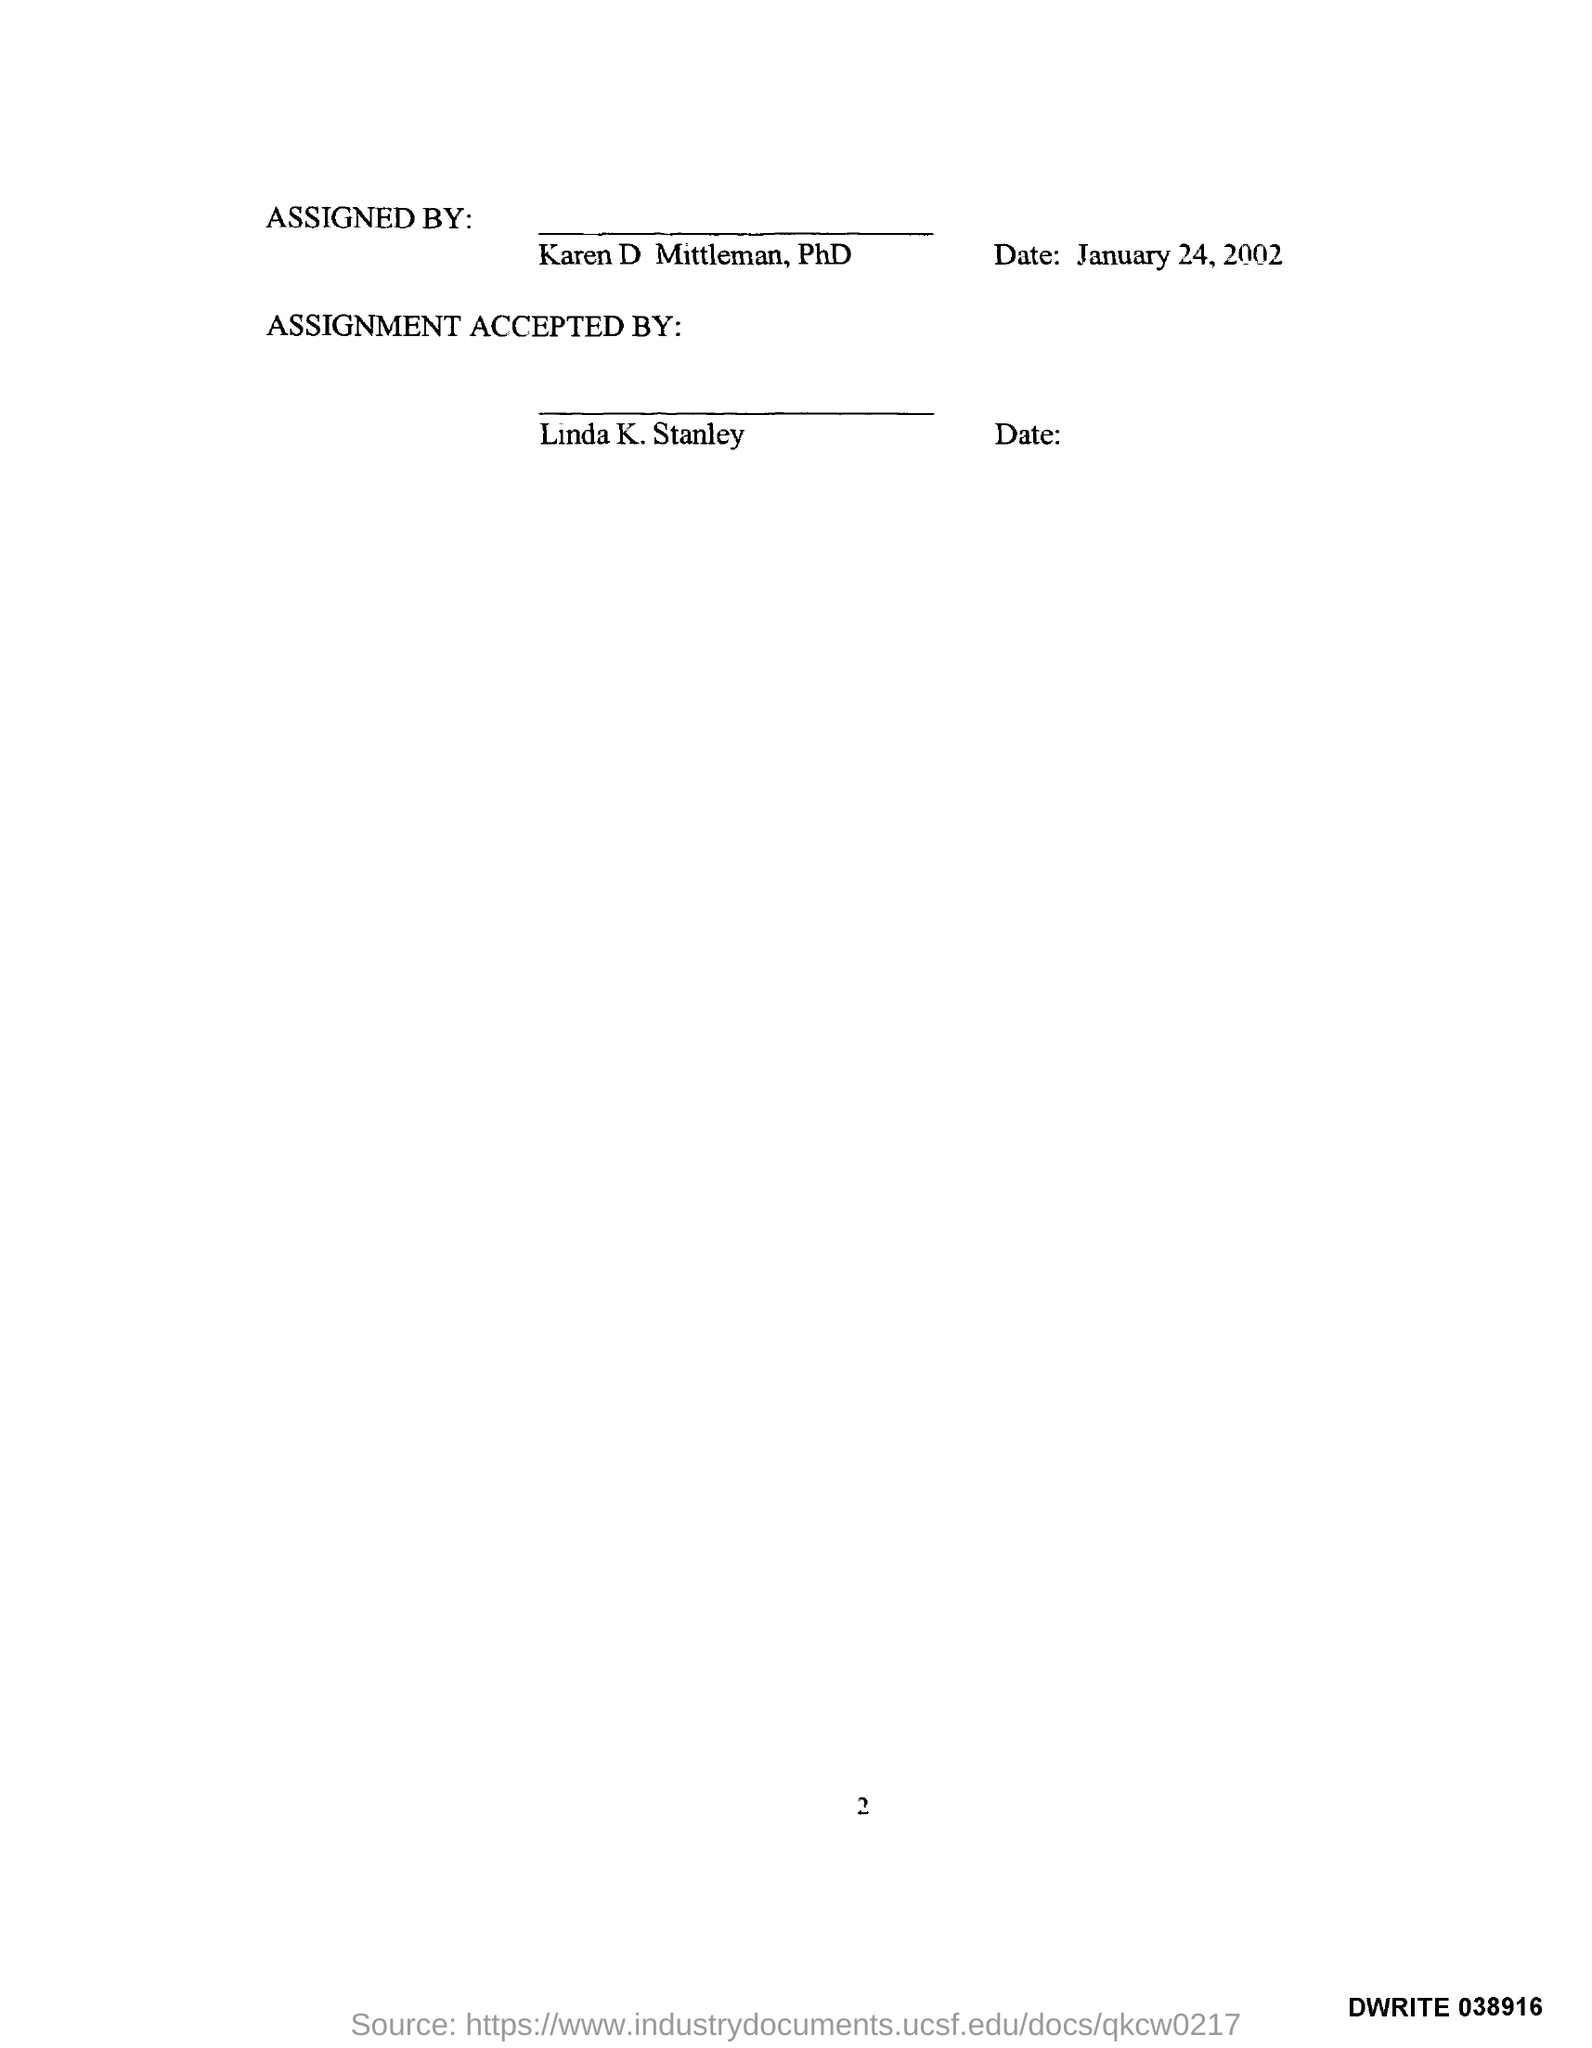Can you tell me the date when this document was assigned? The document was assigned on January 24, 2002, as noted at the top right corner next to the 'ASSIGNED BY:' section. 